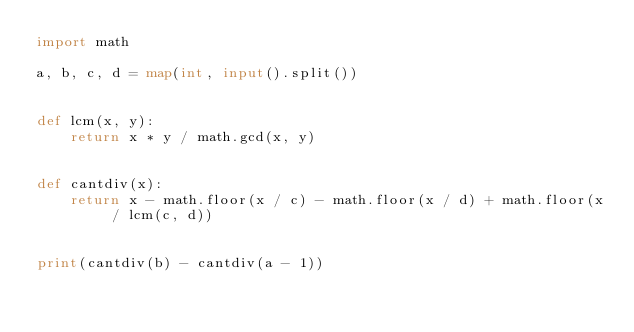Convert code to text. <code><loc_0><loc_0><loc_500><loc_500><_Python_>import math

a, b, c, d = map(int, input().split())


def lcm(x, y):
    return x * y / math.gcd(x, y)


def cantdiv(x):
    return x - math.floor(x / c) - math.floor(x / d) + math.floor(x / lcm(c, d))


print(cantdiv(b) - cantdiv(a - 1))
</code> 